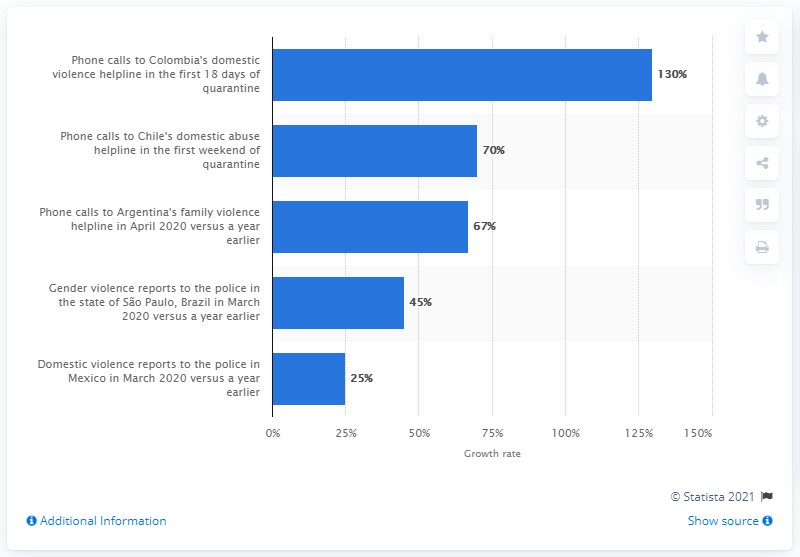Specify some key components in this picture. In March of 2020, there was a significant increase in the number of reported cases of domestic violence in Mexico. 